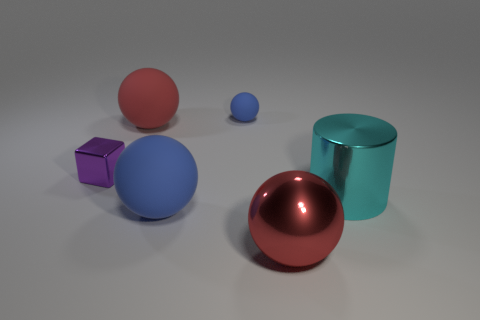Subtract all cyan balls. Subtract all blue cylinders. How many balls are left? 4 Add 4 tiny rubber balls. How many objects exist? 10 Subtract all spheres. How many objects are left? 2 Subtract 0 green balls. How many objects are left? 6 Subtract all large red metallic objects. Subtract all cyan shiny cylinders. How many objects are left? 4 Add 5 small blue objects. How many small blue objects are left? 6 Add 1 small red rubber cylinders. How many small red rubber cylinders exist? 1 